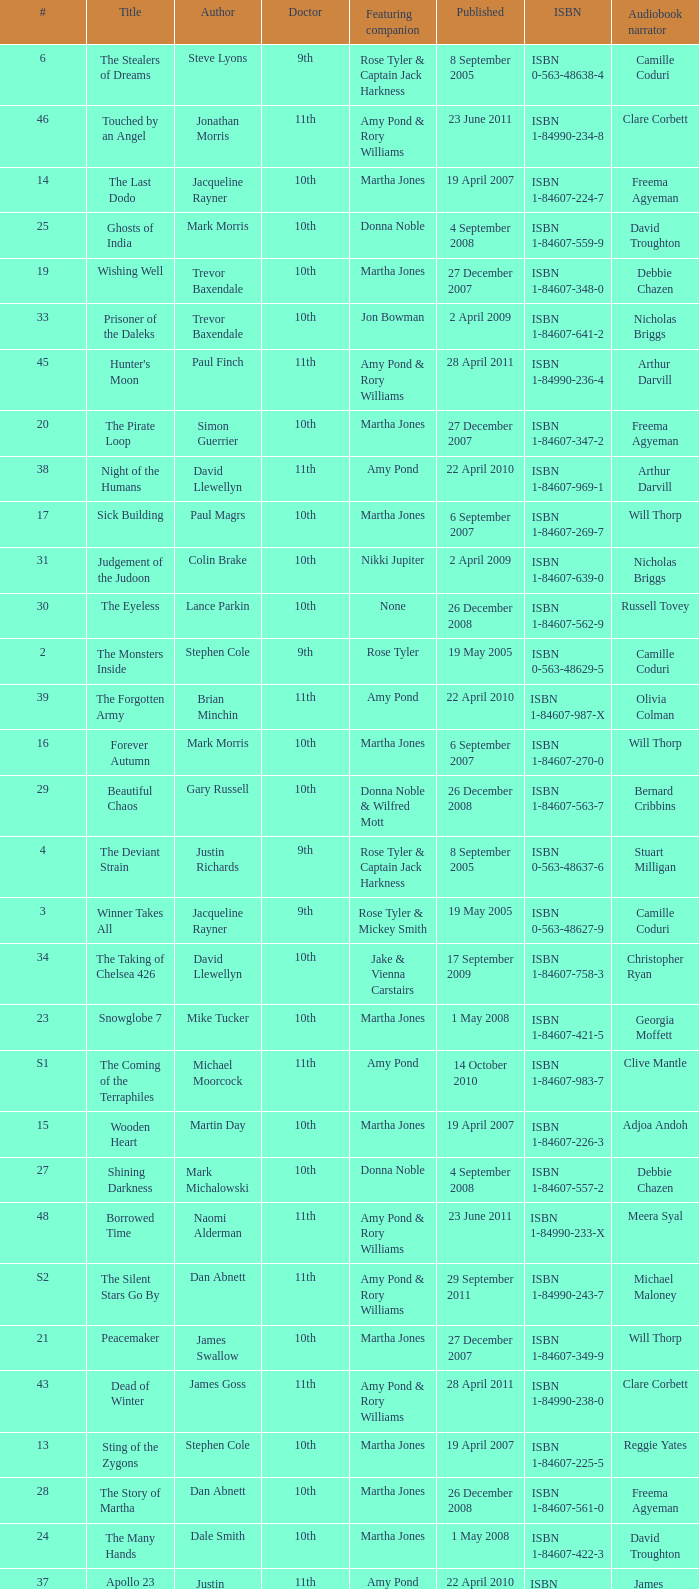What is the title of book number 8? The Feast of the Drowned. 